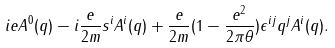Convert formula to latex. <formula><loc_0><loc_0><loc_500><loc_500>i e A ^ { 0 } ( q ) - i \frac { e } { 2 m } s ^ { i } A ^ { i } ( q ) + \frac { e } { 2 m } ( 1 - \frac { e ^ { 2 } } { 2 \pi \theta } ) \epsilon ^ { i j } q ^ { j } A ^ { i } ( q ) .</formula> 